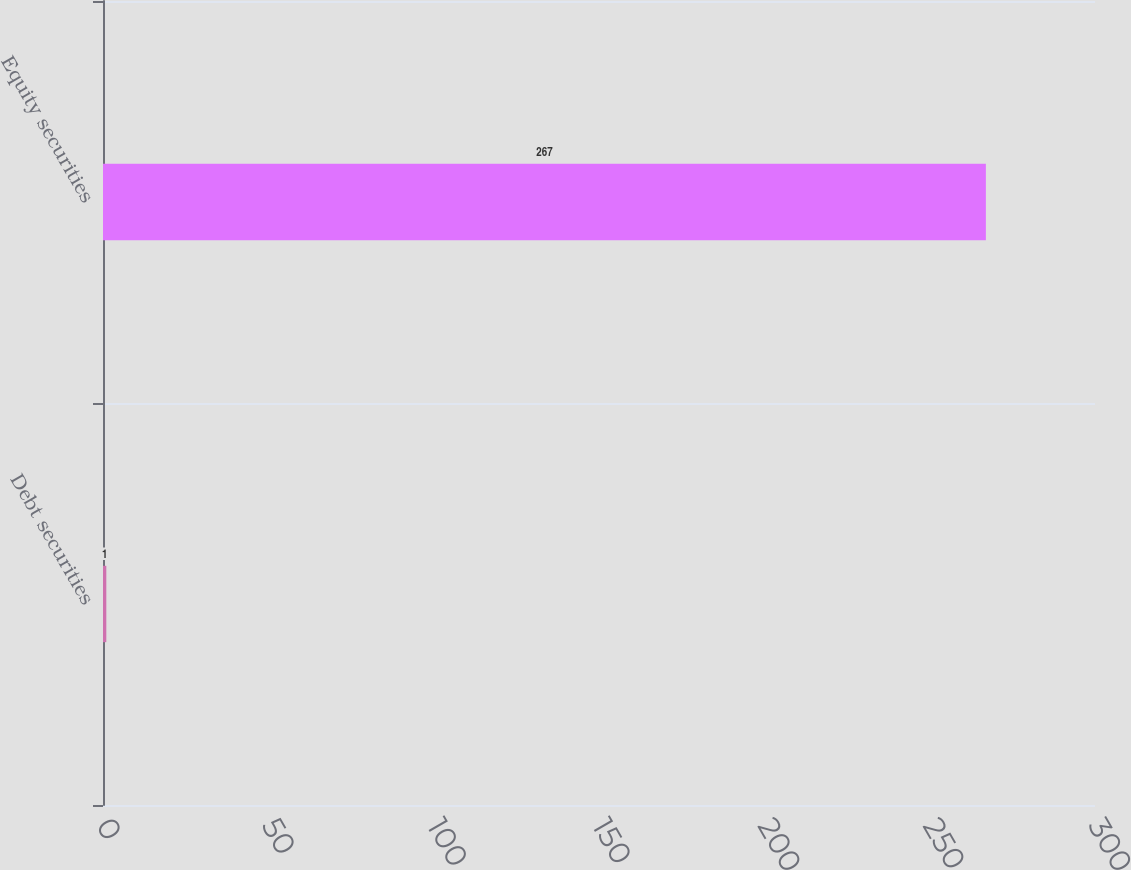Convert chart. <chart><loc_0><loc_0><loc_500><loc_500><bar_chart><fcel>Debt securities<fcel>Equity securities<nl><fcel>1<fcel>267<nl></chart> 